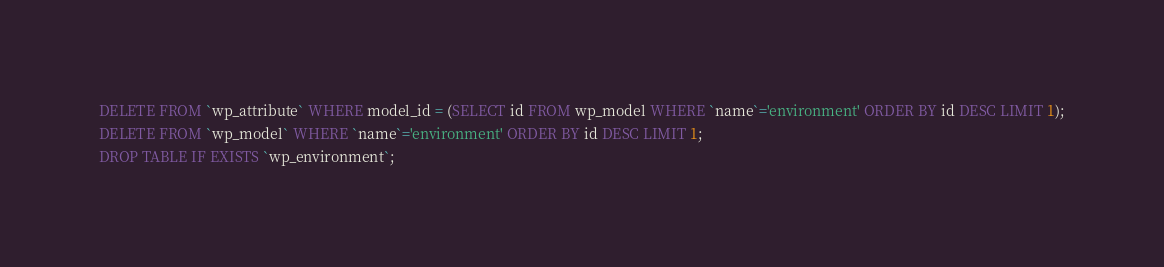Convert code to text. <code><loc_0><loc_0><loc_500><loc_500><_SQL_>DELETE FROM `wp_attribute` WHERE model_id = (SELECT id FROM wp_model WHERE `name`='environment' ORDER BY id DESC LIMIT 1);
DELETE FROM `wp_model` WHERE `name`='environment' ORDER BY id DESC LIMIT 1;
DROP TABLE IF EXISTS `wp_environment`;</code> 